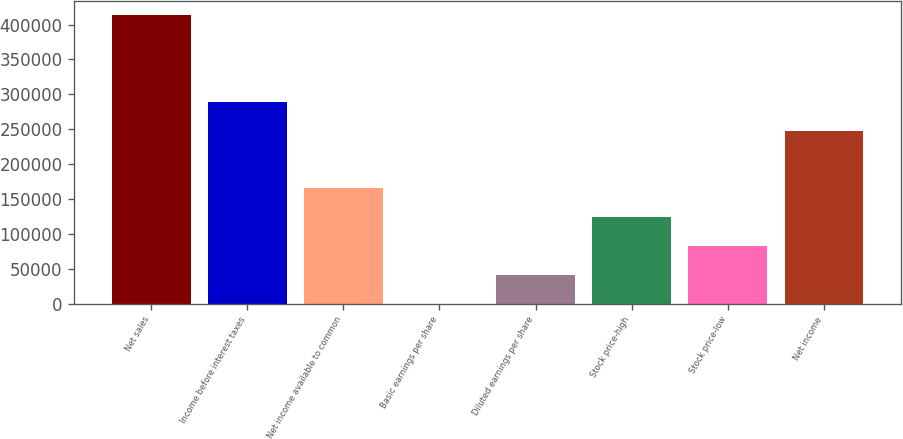Convert chart. <chart><loc_0><loc_0><loc_500><loc_500><bar_chart><fcel>Net sales<fcel>Income before interest taxes<fcel>Net income available to common<fcel>Basic earnings per share<fcel>Diluted earnings per share<fcel>Stock price-high<fcel>Stock price-low<fcel>Net income<nl><fcel>413112<fcel>289178<fcel>165245<fcel>0.17<fcel>41311.3<fcel>123934<fcel>82622.5<fcel>247867<nl></chart> 